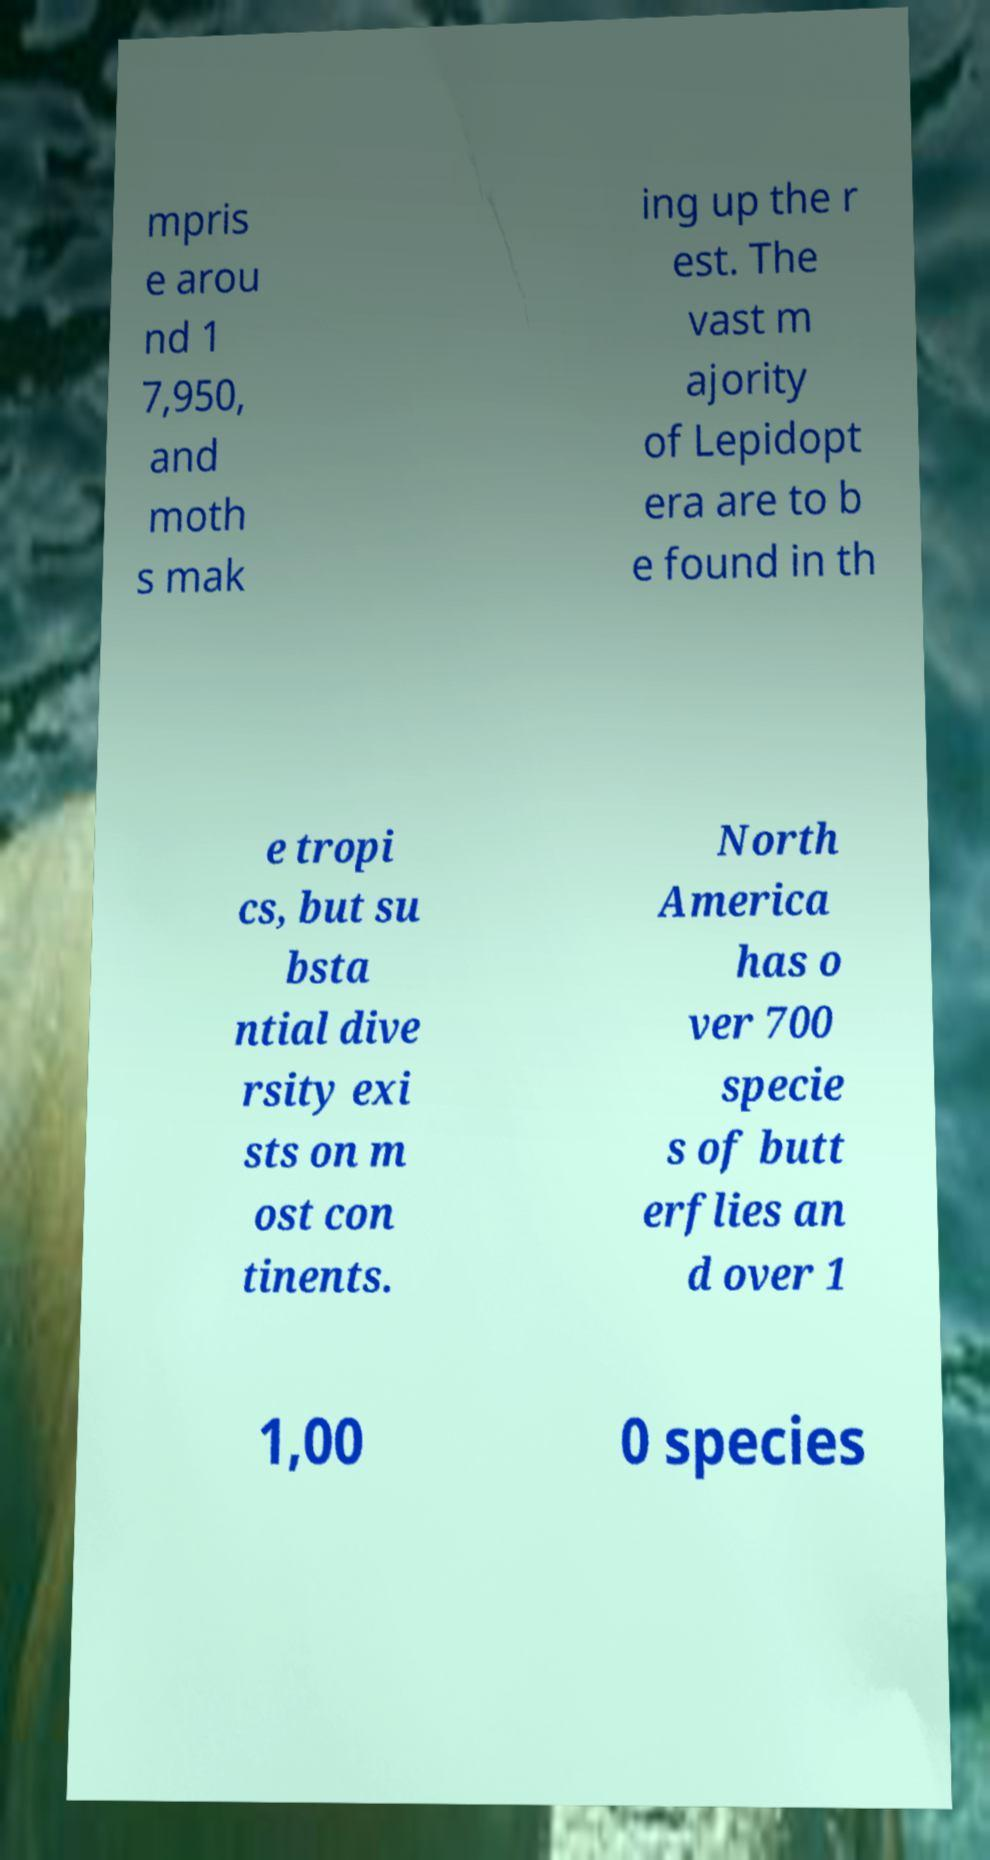For documentation purposes, I need the text within this image transcribed. Could you provide that? mpris e arou nd 1 7,950, and moth s mak ing up the r est. The vast m ajority of Lepidopt era are to b e found in th e tropi cs, but su bsta ntial dive rsity exi sts on m ost con tinents. North America has o ver 700 specie s of butt erflies an d over 1 1,00 0 species 